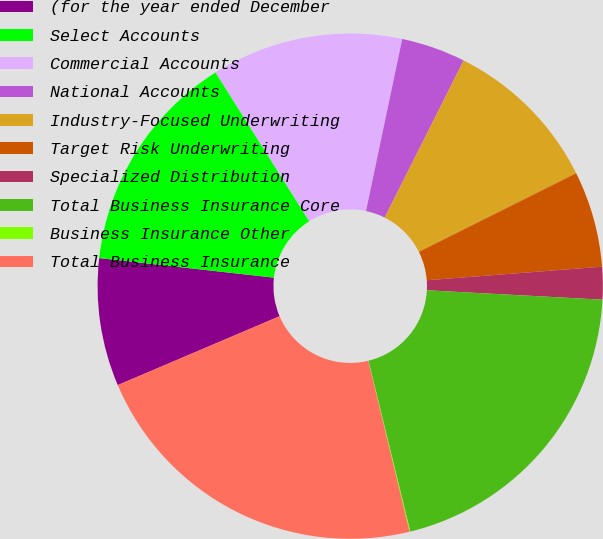Convert chart. <chart><loc_0><loc_0><loc_500><loc_500><pie_chart><fcel>(for the year ended December<fcel>Select Accounts<fcel>Commercial Accounts<fcel>National Accounts<fcel>Industry-Focused Underwriting<fcel>Target Risk Underwriting<fcel>Specialized Distribution<fcel>Total Business Insurance Core<fcel>Business Insurance Other<fcel>Total Business Insurance<nl><fcel>8.18%<fcel>14.28%<fcel>12.25%<fcel>4.11%<fcel>10.21%<fcel>6.15%<fcel>2.08%<fcel>20.33%<fcel>0.05%<fcel>22.37%<nl></chart> 